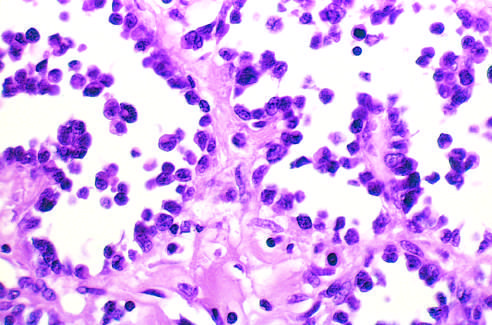what is alveolar rhabdomyosarcoma with numerous spaces lined by?
Answer the question using a single word or phrase. Discohesive 